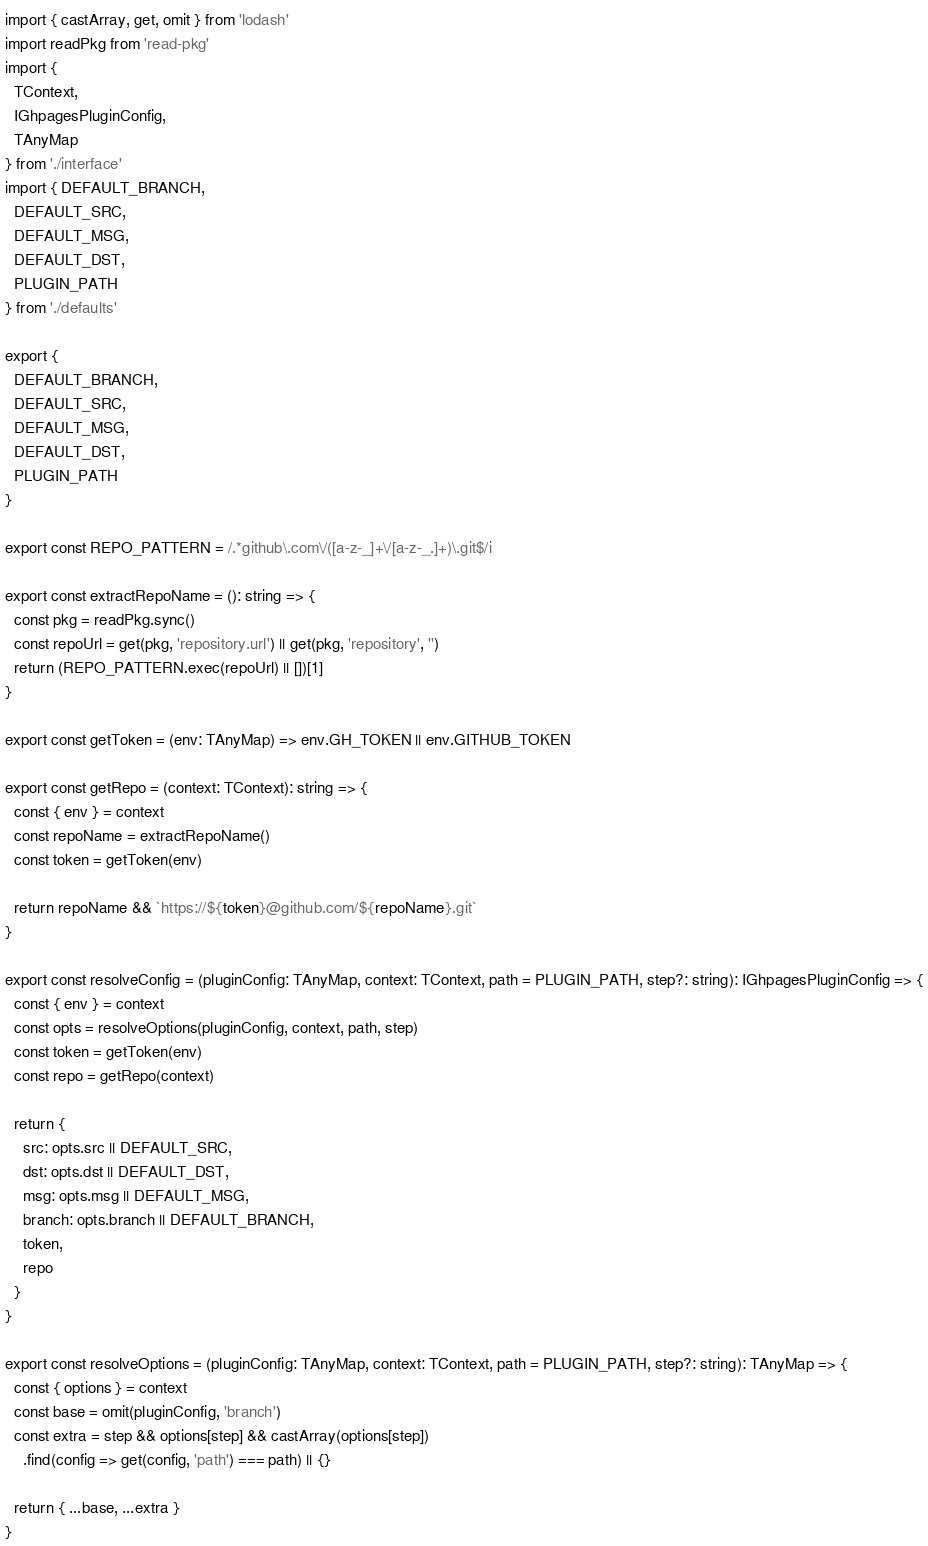<code> <loc_0><loc_0><loc_500><loc_500><_TypeScript_>import { castArray, get, omit } from 'lodash'
import readPkg from 'read-pkg'
import {
  TContext,
  IGhpagesPluginConfig,
  TAnyMap
} from './interface'
import { DEFAULT_BRANCH,
  DEFAULT_SRC,
  DEFAULT_MSG,
  DEFAULT_DST,
  PLUGIN_PATH
} from './defaults'

export {
  DEFAULT_BRANCH,
  DEFAULT_SRC,
  DEFAULT_MSG,
  DEFAULT_DST,
  PLUGIN_PATH
}

export const REPO_PATTERN = /.*github\.com\/([a-z-_]+\/[a-z-_.]+)\.git$/i

export const extractRepoName = (): string => {
  const pkg = readPkg.sync()
  const repoUrl = get(pkg, 'repository.url') || get(pkg, 'repository', '')
  return (REPO_PATTERN.exec(repoUrl) || [])[1]
}

export const getToken = (env: TAnyMap) => env.GH_TOKEN || env.GITHUB_TOKEN

export const getRepo = (context: TContext): string => {
  const { env } = context
  const repoName = extractRepoName()
  const token = getToken(env)

  return repoName && `https://${token}@github.com/${repoName}.git`
}

export const resolveConfig = (pluginConfig: TAnyMap, context: TContext, path = PLUGIN_PATH, step?: string): IGhpagesPluginConfig => {
  const { env } = context
  const opts = resolveOptions(pluginConfig, context, path, step)
  const token = getToken(env)
  const repo = getRepo(context)

  return {
    src: opts.src || DEFAULT_SRC,
    dst: opts.dst || DEFAULT_DST,
    msg: opts.msg || DEFAULT_MSG,
    branch: opts.branch || DEFAULT_BRANCH,
    token,
    repo
  }
}

export const resolveOptions = (pluginConfig: TAnyMap, context: TContext, path = PLUGIN_PATH, step?: string): TAnyMap => {
  const { options } = context
  const base = omit(pluginConfig, 'branch')
  const extra = step && options[step] && castArray(options[step])
    .find(config => get(config, 'path') === path) || {}

  return { ...base, ...extra }
}
</code> 